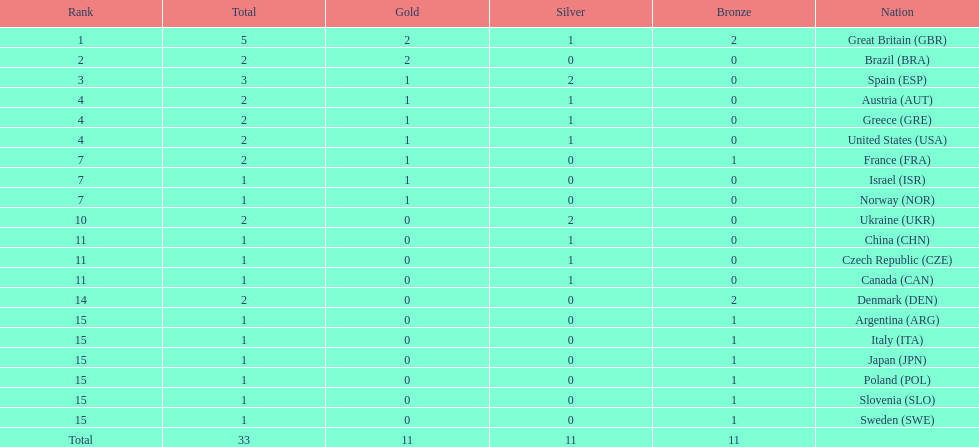How many countries won at least 1 gold and 1 silver medal? 5. 